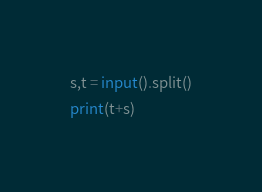Convert code to text. <code><loc_0><loc_0><loc_500><loc_500><_Python_>s,t = input().split()
print(t+s)</code> 